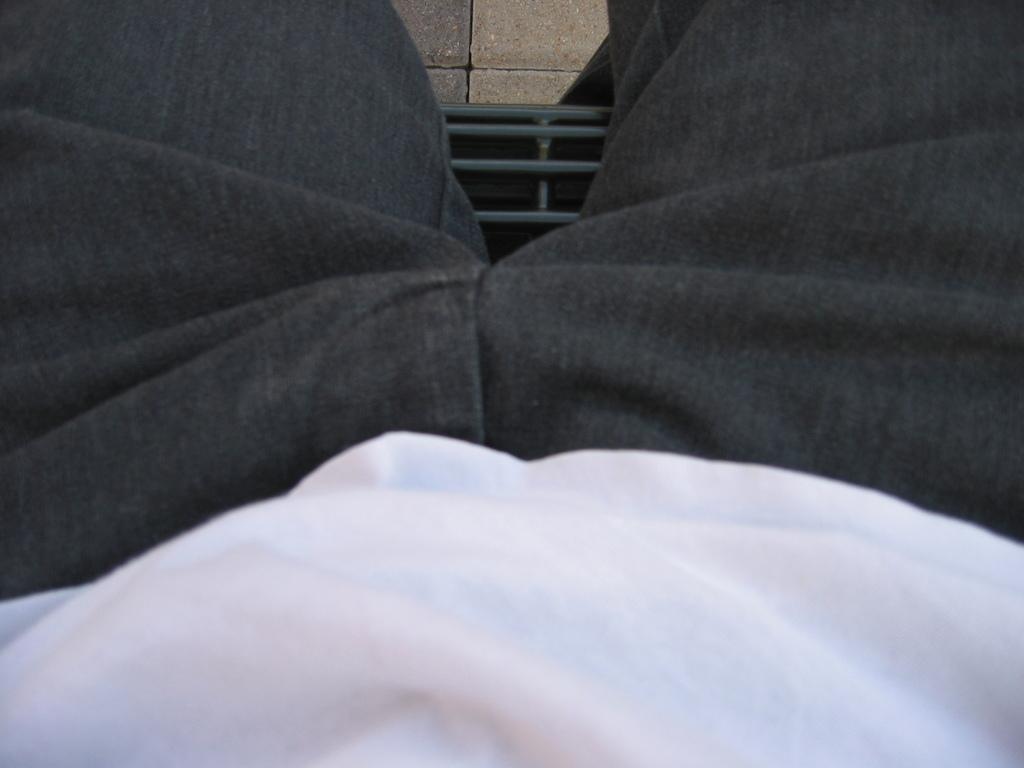What is the primary subject in the image? There is a person sitting in the image. What can be seen beneath the person? The floor is visible in the image. What type of ornament is hanging from the person's ear in the image? There is no ornament visible in the image; only the person sitting and the floor are present. 